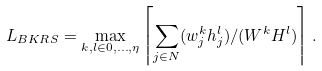Convert formula to latex. <formula><loc_0><loc_0><loc_500><loc_500>L _ { B K R S } = \max _ { k , l \in 0 , \dots , \eta } \left \lceil \sum _ { j \in N } ( w _ { j } ^ { k } h _ { j } ^ { l } ) / ( W ^ { k } H ^ { l } ) \right \rceil .</formula> 